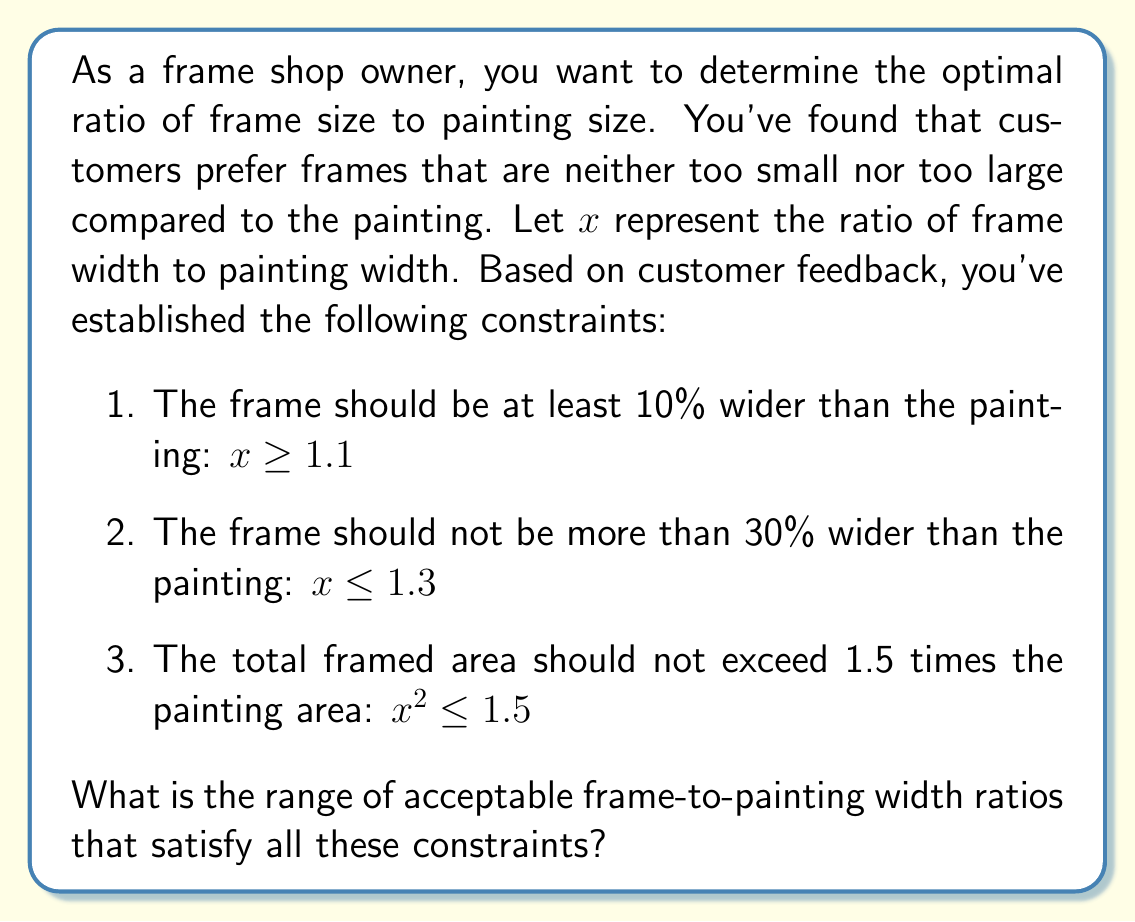Teach me how to tackle this problem. Let's approach this step-by-step:

1) We have three inequalities to consider:
   a) $x \geq 1.1$
   b) $x \leq 1.3$
   c) $x^2 \leq 1.5$

2) The first two inequalities give us a range for $x$:
   $1.1 \leq x \leq 1.3$

3) For the third inequality, we need to solve $x^2 \leq 1.5$:
   $x^2 \leq 1.5$
   $-\sqrt{1.5} \leq x \leq \sqrt{1.5}$
   $x \leq \sqrt{1.5} \approx 1.225$ (since $x$ is positive in this context)

4) Now we need to find the intersection of these ranges:
   $1.1 \leq x \leq 1.225$

5) This means the frame width should be between 110% and 122.5% of the painting width.

6) We can express this as a ratio range:
   $1.1:1$ to $1.225:1$
Answer: $1.1:1$ to $1.225:1$ 